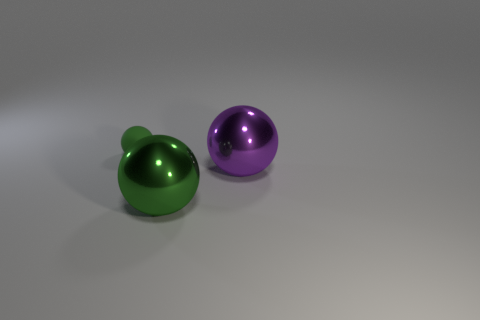Subtract all green spheres. How many spheres are left? 1 Add 2 small green matte things. How many objects exist? 5 Subtract all green balls. How many balls are left? 1 Subtract all cyan balls. Subtract all yellow blocks. How many balls are left? 3 Subtract all yellow blocks. How many purple spheres are left? 1 Subtract all yellow rubber cubes. Subtract all large shiny things. How many objects are left? 1 Add 2 large shiny objects. How many large shiny objects are left? 4 Add 2 big brown rubber cylinders. How many big brown rubber cylinders exist? 2 Subtract 0 red blocks. How many objects are left? 3 Subtract 1 balls. How many balls are left? 2 